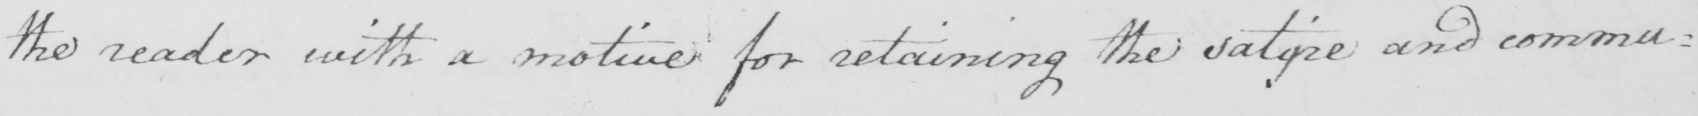What is written in this line of handwriting? the reader with a motive for retaining the satyre and communicating 